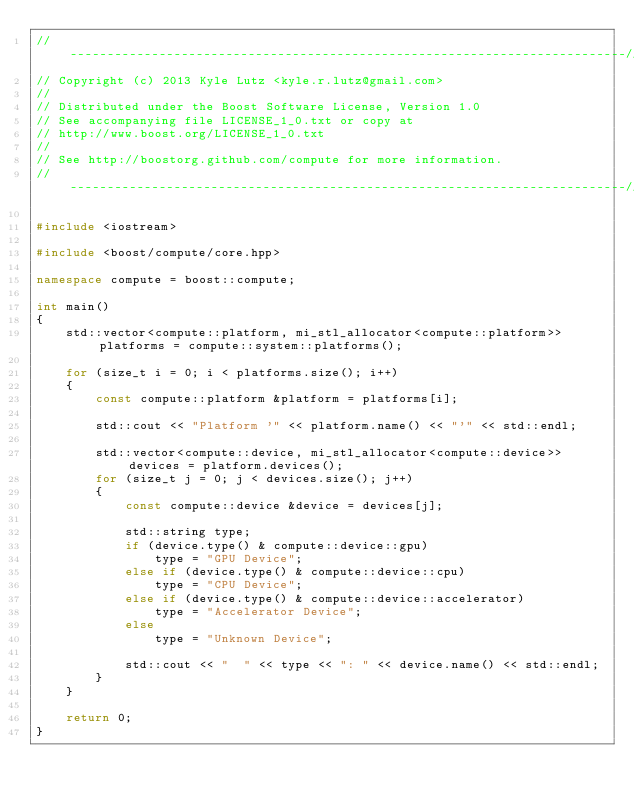<code> <loc_0><loc_0><loc_500><loc_500><_C++_>//---------------------------------------------------------------------------//
// Copyright (c) 2013 Kyle Lutz <kyle.r.lutz@gmail.com>
//
// Distributed under the Boost Software License, Version 1.0
// See accompanying file LICENSE_1_0.txt or copy at
// http://www.boost.org/LICENSE_1_0.txt
//
// See http://boostorg.github.com/compute for more information.
//---------------------------------------------------------------------------//

#include <iostream>

#include <boost/compute/core.hpp>

namespace compute = boost::compute;

int main()
{
    std::vector<compute::platform, mi_stl_allocator<compute::platform>> platforms = compute::system::platforms();

    for (size_t i = 0; i < platforms.size(); i++)
    {
        const compute::platform &platform = platforms[i];

        std::cout << "Platform '" << platform.name() << "'" << std::endl;

        std::vector<compute::device, mi_stl_allocator<compute::device>> devices = platform.devices();
        for (size_t j = 0; j < devices.size(); j++)
        {
            const compute::device &device = devices[j];

            std::string type;
            if (device.type() & compute::device::gpu)
                type = "GPU Device";
            else if (device.type() & compute::device::cpu)
                type = "CPU Device";
            else if (device.type() & compute::device::accelerator)
                type = "Accelerator Device";
            else
                type = "Unknown Device";

            std::cout << "  " << type << ": " << device.name() << std::endl;
        }
    }

    return 0;
}
</code> 